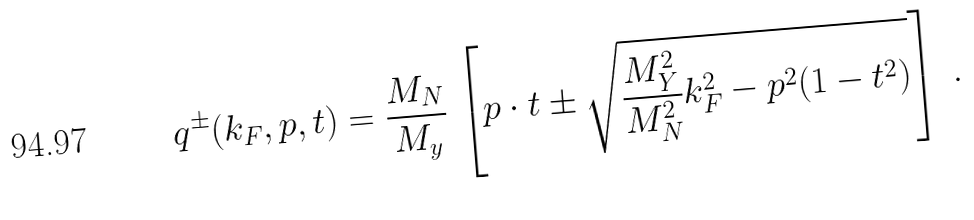Convert formula to latex. <formula><loc_0><loc_0><loc_500><loc_500>q ^ { \pm } ( k _ { F } , p , t ) = \frac { M _ { N } } { M _ { y } } \, \left [ p \cdot t \pm \sqrt { \frac { M _ { Y } ^ { 2 } } { M _ { N } ^ { 2 } } k ^ { 2 } _ { F } - p ^ { 2 } ( 1 - t ^ { 2 } ) } \right ] \ .</formula> 